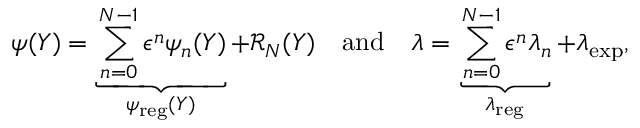<formula> <loc_0><loc_0><loc_500><loc_500>\psi ( Y ) = \underbrace { \sum _ { n = 0 } ^ { N - 1 } \epsilon ^ { n } \psi _ { n } ( Y ) } _ { \psi _ { r e g } ( Y ) } + \mathcal { R } _ { N } ( Y ) \quad a n d \quad \lambda = \underbrace { \sum _ { n = 0 } ^ { N - 1 } \epsilon ^ { n } \lambda _ { n } } _ { \lambda _ { r e g } } + \lambda _ { e x p } ,</formula> 